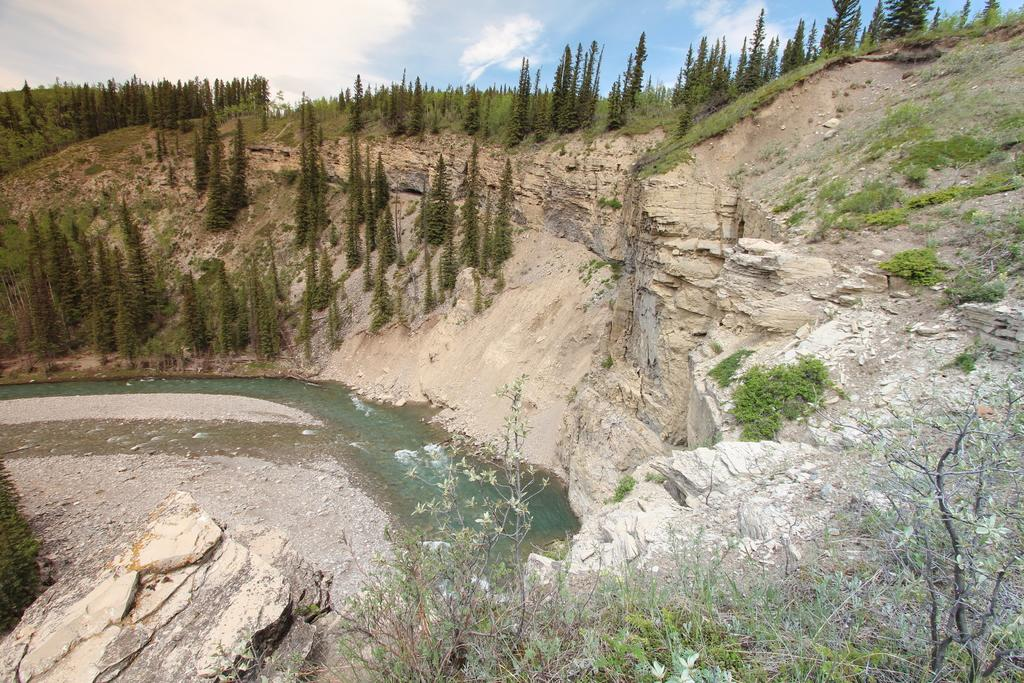What type of vegetation can be seen in the image? There is grass, plants, and trees visible in the image. What natural element is present in the image? There is water visible in the image. What is the terrain like in the image? There is a hill in the image. What is visible in the background of the image? The sky is visible in the background of the image. What atmospheric conditions can be observed in the sky? There are clouds in the sky. Where is the door located in the image? There is no door present in the image. What type of house can be seen in the image? There is no house present in the image. 